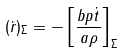<formula> <loc_0><loc_0><loc_500><loc_500>( \dot { r } ) _ { \Sigma } = - \left [ \frac { b p \dot { t } } { a \rho } \right ] _ { \Sigma }</formula> 